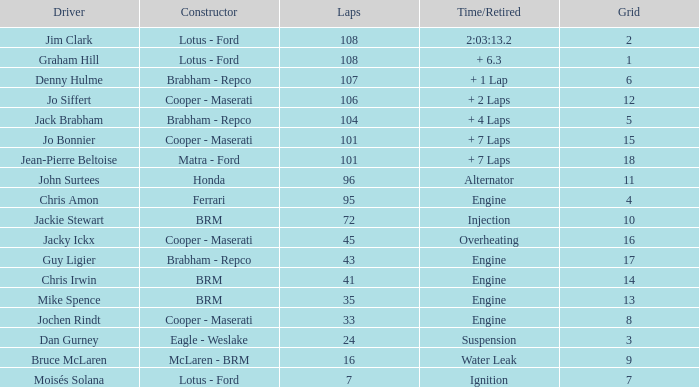What was the grid for suspension time/retired? 3.0. 